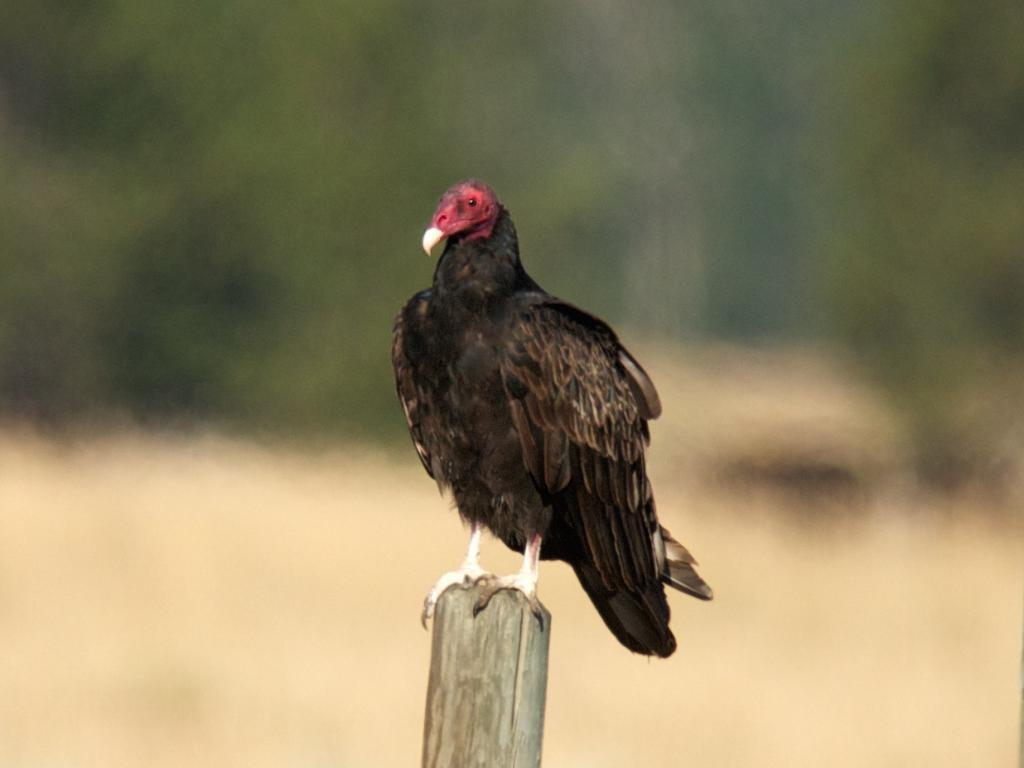What type of animal can be seen in the image? There is a bird in the image. What is the bird standing on? The bird is standing on a wooden object. Where is the bird located in the image? The bird is located in the middle of the image. What type of beef is being served in the morning at the library in the image? There is no library, beef, or morning mentioned in the image; it features a bird standing on a wooden object. 